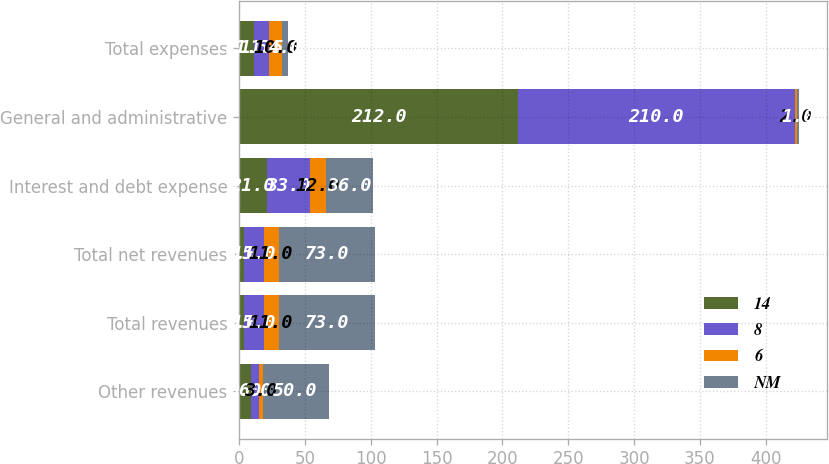<chart> <loc_0><loc_0><loc_500><loc_500><stacked_bar_chart><ecel><fcel>Other revenues<fcel>Total revenues<fcel>Total net revenues<fcel>Interest and debt expense<fcel>General and administrative<fcel>Total expenses<nl><fcel>14<fcel>9<fcel>4<fcel>4<fcel>21<fcel>212<fcel>11.5<nl><fcel>8<fcel>6<fcel>15<fcel>15<fcel>33<fcel>210<fcel>11.5<nl><fcel>6<fcel>3<fcel>11<fcel>11<fcel>12<fcel>2<fcel>10<nl><fcel>NM<fcel>50<fcel>73<fcel>73<fcel>36<fcel>1<fcel>4<nl></chart> 